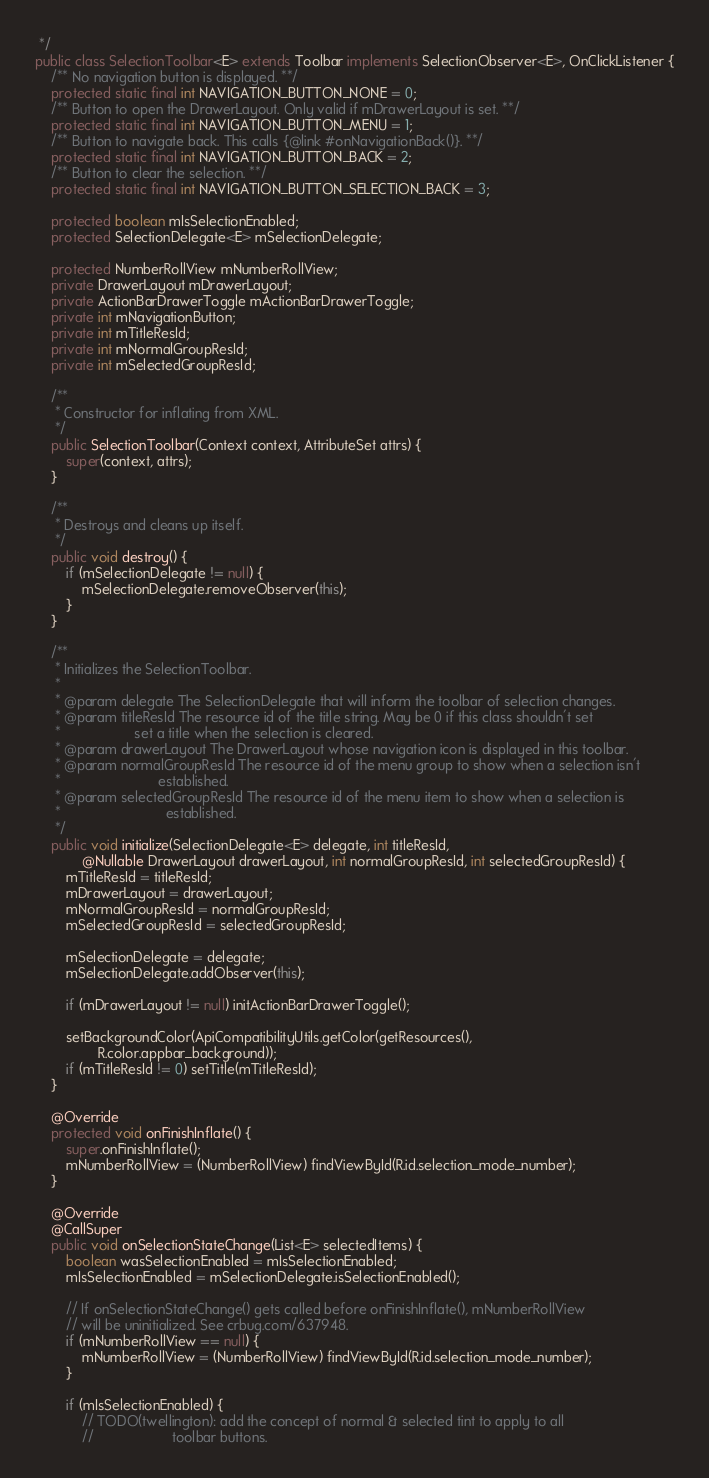<code> <loc_0><loc_0><loc_500><loc_500><_Java_> */
public class SelectionToolbar<E> extends Toolbar implements SelectionObserver<E>, OnClickListener {
    /** No navigation button is displayed. **/
    protected static final int NAVIGATION_BUTTON_NONE = 0;
    /** Button to open the DrawerLayout. Only valid if mDrawerLayout is set. **/
    protected static final int NAVIGATION_BUTTON_MENU = 1;
    /** Button to navigate back. This calls {@link #onNavigationBack()}. **/
    protected static final int NAVIGATION_BUTTON_BACK = 2;
    /** Button to clear the selection. **/
    protected static final int NAVIGATION_BUTTON_SELECTION_BACK = 3;

    protected boolean mIsSelectionEnabled;
    protected SelectionDelegate<E> mSelectionDelegate;

    protected NumberRollView mNumberRollView;
    private DrawerLayout mDrawerLayout;
    private ActionBarDrawerToggle mActionBarDrawerToggle;
    private int mNavigationButton;
    private int mTitleResId;
    private int mNormalGroupResId;
    private int mSelectedGroupResId;

    /**
     * Constructor for inflating from XML.
     */
    public SelectionToolbar(Context context, AttributeSet attrs) {
        super(context, attrs);
    }

    /**
     * Destroys and cleans up itself.
     */
    public void destroy() {
        if (mSelectionDelegate != null) {
            mSelectionDelegate.removeObserver(this);
        }
    }

    /**
     * Initializes the SelectionToolbar.
     *
     * @param delegate The SelectionDelegate that will inform the toolbar of selection changes.
     * @param titleResId The resource id of the title string. May be 0 if this class shouldn't set
     *                   set a title when the selection is cleared.
     * @param drawerLayout The DrawerLayout whose navigation icon is displayed in this toolbar.
     * @param normalGroupResId The resource id of the menu group to show when a selection isn't
     *                         established.
     * @param selectedGroupResId The resource id of the menu item to show when a selection is
     *                           established.
     */
    public void initialize(SelectionDelegate<E> delegate, int titleResId,
            @Nullable DrawerLayout drawerLayout, int normalGroupResId, int selectedGroupResId) {
        mTitleResId = titleResId;
        mDrawerLayout = drawerLayout;
        mNormalGroupResId = normalGroupResId;
        mSelectedGroupResId = selectedGroupResId;

        mSelectionDelegate = delegate;
        mSelectionDelegate.addObserver(this);

        if (mDrawerLayout != null) initActionBarDrawerToggle();

        setBackgroundColor(ApiCompatibilityUtils.getColor(getResources(),
                R.color.appbar_background));
        if (mTitleResId != 0) setTitle(mTitleResId);
    }

    @Override
    protected void onFinishInflate() {
        super.onFinishInflate();
        mNumberRollView = (NumberRollView) findViewById(R.id.selection_mode_number);
    }

    @Override
    @CallSuper
    public void onSelectionStateChange(List<E> selectedItems) {
        boolean wasSelectionEnabled = mIsSelectionEnabled;
        mIsSelectionEnabled = mSelectionDelegate.isSelectionEnabled();

        // If onSelectionStateChange() gets called before onFinishInflate(), mNumberRollView
        // will be uninitialized. See crbug.com/637948.
        if (mNumberRollView == null) {
            mNumberRollView = (NumberRollView) findViewById(R.id.selection_mode_number);
        }

        if (mIsSelectionEnabled) {
            // TODO(twellington): add the concept of normal & selected tint to apply to all
            //                    toolbar buttons.</code> 